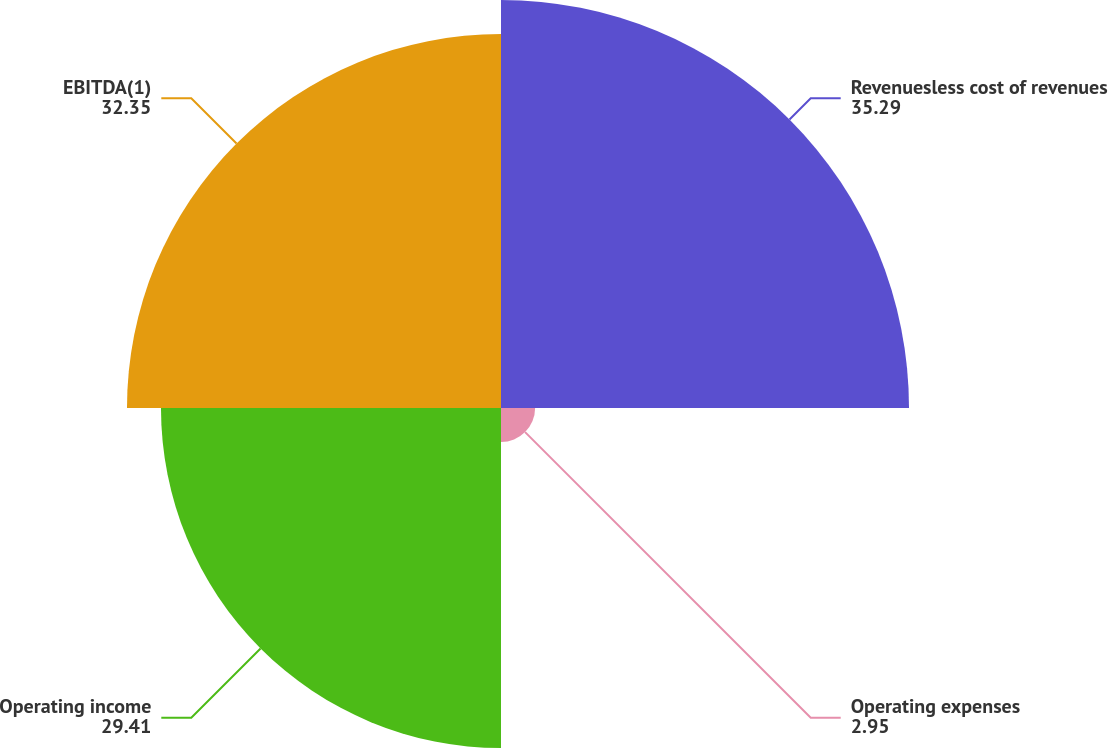<chart> <loc_0><loc_0><loc_500><loc_500><pie_chart><fcel>Revenuesless cost of revenues<fcel>Operating expenses<fcel>Operating income<fcel>EBITDA(1)<nl><fcel>35.29%<fcel>2.95%<fcel>29.41%<fcel>32.35%<nl></chart> 